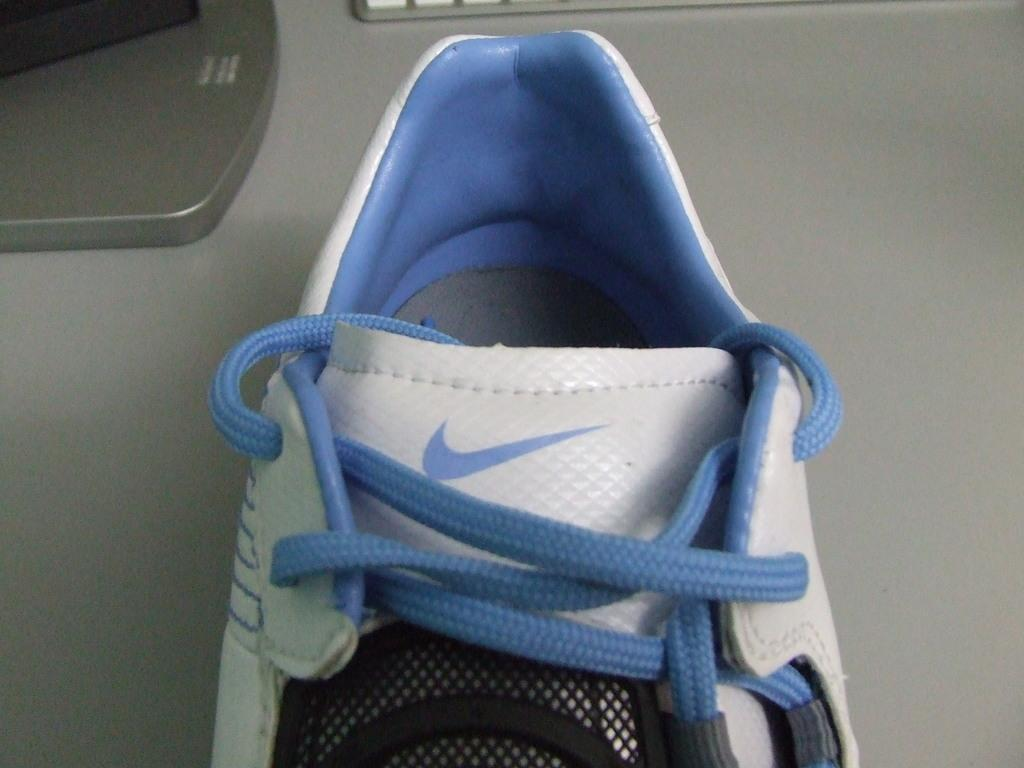What is the main subject of the image? There is a shoe in the image. Where is the shoe located in the image? The shoe is towards the bottom of the image. What can be seen in the upper part of the image? There are objects towards the top of the image. What is the color of the background in the image? The background of the image is white in color. What type of education can be seen in the image? There is no reference to education in the image; it features a shoe and other objects. Can you provide an example of a change that occurs in the image? There is no change occurring in the image; it is a static representation of the shoe and other objects. 